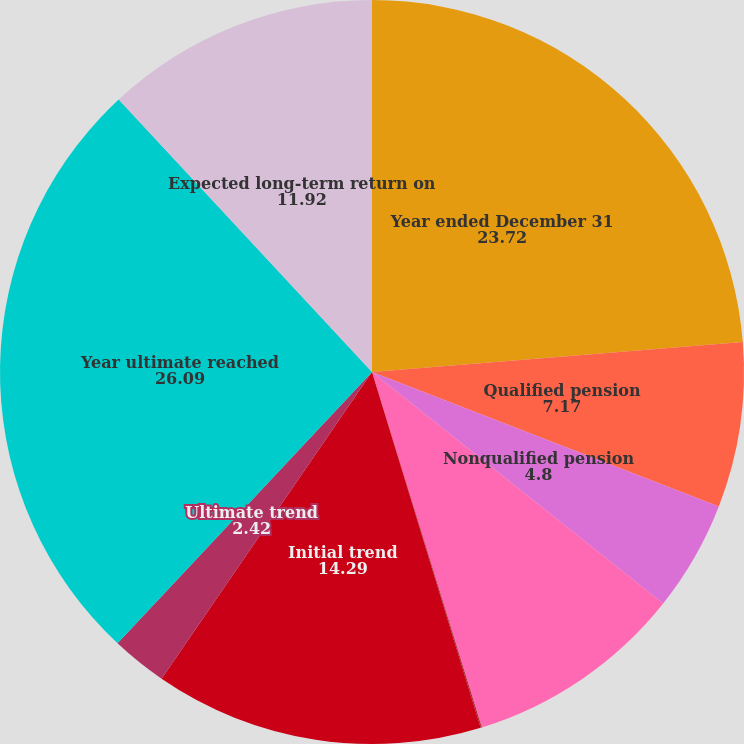Convert chart. <chart><loc_0><loc_0><loc_500><loc_500><pie_chart><fcel>Year ended December 31<fcel>Qualified pension<fcel>Nonqualified pension<fcel>Postretirement benefits<fcel>Rate of compensation increase<fcel>Initial trend<fcel>Ultimate trend<fcel>Year ultimate reached<fcel>Expected long-term return on<nl><fcel>23.72%<fcel>7.17%<fcel>4.8%<fcel>9.54%<fcel>0.05%<fcel>14.29%<fcel>2.42%<fcel>26.09%<fcel>11.92%<nl></chart> 